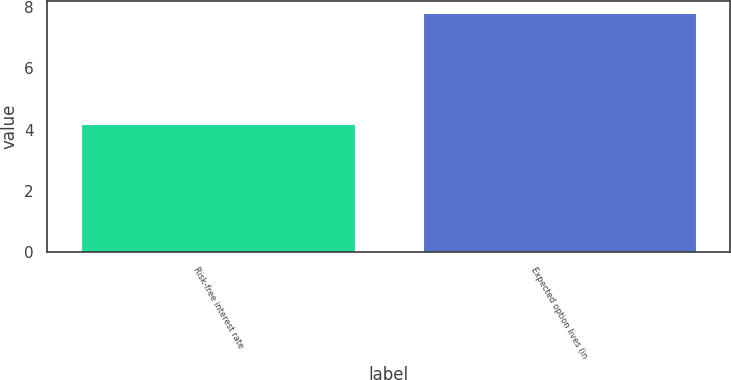<chart> <loc_0><loc_0><loc_500><loc_500><bar_chart><fcel>Risk-free interest rate<fcel>Expected option lives (in<nl><fcel>4.19<fcel>7.8<nl></chart> 